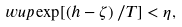Convert formula to latex. <formula><loc_0><loc_0><loc_500><loc_500>\ w u p \exp [ \left ( h - \zeta \right ) / T ] < \eta ,</formula> 